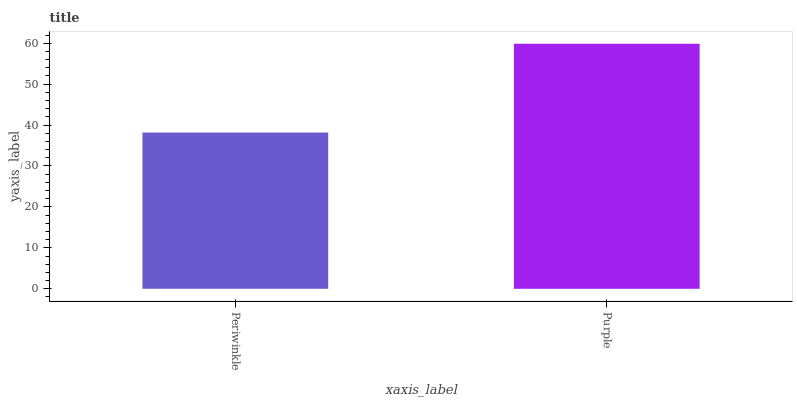Is Periwinkle the minimum?
Answer yes or no. Yes. Is Purple the maximum?
Answer yes or no. Yes. Is Purple the minimum?
Answer yes or no. No. Is Purple greater than Periwinkle?
Answer yes or no. Yes. Is Periwinkle less than Purple?
Answer yes or no. Yes. Is Periwinkle greater than Purple?
Answer yes or no. No. Is Purple less than Periwinkle?
Answer yes or no. No. Is Purple the high median?
Answer yes or no. Yes. Is Periwinkle the low median?
Answer yes or no. Yes. Is Periwinkle the high median?
Answer yes or no. No. Is Purple the low median?
Answer yes or no. No. 